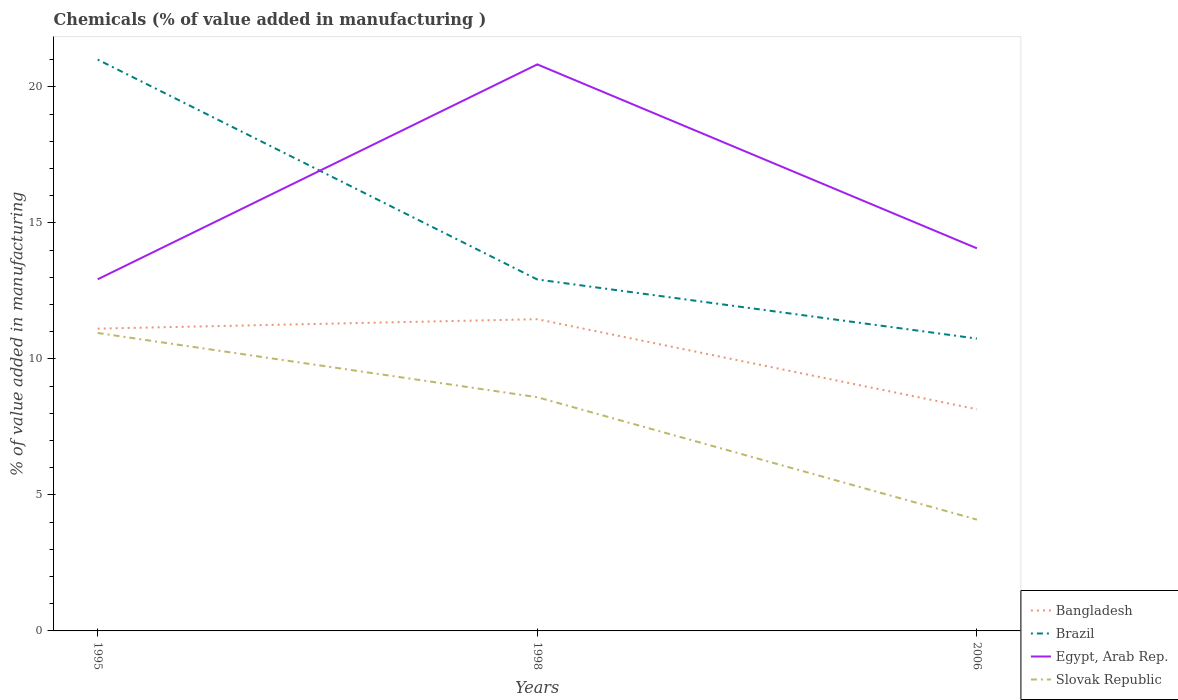Does the line corresponding to Bangladesh intersect with the line corresponding to Slovak Republic?
Give a very brief answer. No. Across all years, what is the maximum value added in manufacturing chemicals in Bangladesh?
Ensure brevity in your answer.  8.15. What is the total value added in manufacturing chemicals in Brazil in the graph?
Your answer should be very brief. 8.09. What is the difference between the highest and the second highest value added in manufacturing chemicals in Brazil?
Keep it short and to the point. 10.26. What is the difference between the highest and the lowest value added in manufacturing chemicals in Egypt, Arab Rep.?
Make the answer very short. 1. Is the value added in manufacturing chemicals in Slovak Republic strictly greater than the value added in manufacturing chemicals in Bangladesh over the years?
Ensure brevity in your answer.  Yes. How many lines are there?
Give a very brief answer. 4. What is the difference between two consecutive major ticks on the Y-axis?
Make the answer very short. 5. Are the values on the major ticks of Y-axis written in scientific E-notation?
Keep it short and to the point. No. Does the graph contain grids?
Your response must be concise. No. Where does the legend appear in the graph?
Keep it short and to the point. Bottom right. How are the legend labels stacked?
Your answer should be compact. Vertical. What is the title of the graph?
Make the answer very short. Chemicals (% of value added in manufacturing ). Does "Sierra Leone" appear as one of the legend labels in the graph?
Keep it short and to the point. No. What is the label or title of the X-axis?
Provide a short and direct response. Years. What is the label or title of the Y-axis?
Keep it short and to the point. % of value added in manufacturing. What is the % of value added in manufacturing of Bangladesh in 1995?
Ensure brevity in your answer.  11.11. What is the % of value added in manufacturing in Brazil in 1995?
Provide a short and direct response. 21.01. What is the % of value added in manufacturing in Egypt, Arab Rep. in 1995?
Your answer should be very brief. 12.93. What is the % of value added in manufacturing of Slovak Republic in 1995?
Provide a short and direct response. 10.96. What is the % of value added in manufacturing of Bangladesh in 1998?
Make the answer very short. 11.46. What is the % of value added in manufacturing of Brazil in 1998?
Provide a short and direct response. 12.92. What is the % of value added in manufacturing in Egypt, Arab Rep. in 1998?
Your answer should be very brief. 20.83. What is the % of value added in manufacturing of Slovak Republic in 1998?
Make the answer very short. 8.59. What is the % of value added in manufacturing of Bangladesh in 2006?
Your answer should be very brief. 8.15. What is the % of value added in manufacturing in Brazil in 2006?
Provide a succinct answer. 10.75. What is the % of value added in manufacturing of Egypt, Arab Rep. in 2006?
Your answer should be very brief. 14.07. What is the % of value added in manufacturing in Slovak Republic in 2006?
Your response must be concise. 4.09. Across all years, what is the maximum % of value added in manufacturing of Bangladesh?
Make the answer very short. 11.46. Across all years, what is the maximum % of value added in manufacturing of Brazil?
Your answer should be compact. 21.01. Across all years, what is the maximum % of value added in manufacturing of Egypt, Arab Rep.?
Provide a short and direct response. 20.83. Across all years, what is the maximum % of value added in manufacturing in Slovak Republic?
Provide a succinct answer. 10.96. Across all years, what is the minimum % of value added in manufacturing of Bangladesh?
Provide a short and direct response. 8.15. Across all years, what is the minimum % of value added in manufacturing in Brazil?
Keep it short and to the point. 10.75. Across all years, what is the minimum % of value added in manufacturing of Egypt, Arab Rep.?
Your answer should be compact. 12.93. Across all years, what is the minimum % of value added in manufacturing of Slovak Republic?
Give a very brief answer. 4.09. What is the total % of value added in manufacturing in Bangladesh in the graph?
Give a very brief answer. 30.73. What is the total % of value added in manufacturing of Brazil in the graph?
Make the answer very short. 44.68. What is the total % of value added in manufacturing of Egypt, Arab Rep. in the graph?
Provide a short and direct response. 47.83. What is the total % of value added in manufacturing of Slovak Republic in the graph?
Your answer should be very brief. 23.64. What is the difference between the % of value added in manufacturing of Bangladesh in 1995 and that in 1998?
Your response must be concise. -0.35. What is the difference between the % of value added in manufacturing in Brazil in 1995 and that in 1998?
Give a very brief answer. 8.09. What is the difference between the % of value added in manufacturing in Egypt, Arab Rep. in 1995 and that in 1998?
Provide a short and direct response. -7.9. What is the difference between the % of value added in manufacturing in Slovak Republic in 1995 and that in 1998?
Give a very brief answer. 2.36. What is the difference between the % of value added in manufacturing in Bangladesh in 1995 and that in 2006?
Provide a succinct answer. 2.96. What is the difference between the % of value added in manufacturing of Brazil in 1995 and that in 2006?
Give a very brief answer. 10.26. What is the difference between the % of value added in manufacturing of Egypt, Arab Rep. in 1995 and that in 2006?
Provide a succinct answer. -1.14. What is the difference between the % of value added in manufacturing of Slovak Republic in 1995 and that in 2006?
Your response must be concise. 6.86. What is the difference between the % of value added in manufacturing in Bangladesh in 1998 and that in 2006?
Your answer should be compact. 3.31. What is the difference between the % of value added in manufacturing in Brazil in 1998 and that in 2006?
Offer a terse response. 2.17. What is the difference between the % of value added in manufacturing in Egypt, Arab Rep. in 1998 and that in 2006?
Your answer should be very brief. 6.76. What is the difference between the % of value added in manufacturing in Slovak Republic in 1998 and that in 2006?
Give a very brief answer. 4.5. What is the difference between the % of value added in manufacturing of Bangladesh in 1995 and the % of value added in manufacturing of Brazil in 1998?
Make the answer very short. -1.81. What is the difference between the % of value added in manufacturing of Bangladesh in 1995 and the % of value added in manufacturing of Egypt, Arab Rep. in 1998?
Provide a short and direct response. -9.72. What is the difference between the % of value added in manufacturing in Bangladesh in 1995 and the % of value added in manufacturing in Slovak Republic in 1998?
Make the answer very short. 2.52. What is the difference between the % of value added in manufacturing of Brazil in 1995 and the % of value added in manufacturing of Egypt, Arab Rep. in 1998?
Offer a terse response. 0.18. What is the difference between the % of value added in manufacturing of Brazil in 1995 and the % of value added in manufacturing of Slovak Republic in 1998?
Offer a very short reply. 12.41. What is the difference between the % of value added in manufacturing in Egypt, Arab Rep. in 1995 and the % of value added in manufacturing in Slovak Republic in 1998?
Give a very brief answer. 4.34. What is the difference between the % of value added in manufacturing in Bangladesh in 1995 and the % of value added in manufacturing in Brazil in 2006?
Your answer should be very brief. 0.37. What is the difference between the % of value added in manufacturing of Bangladesh in 1995 and the % of value added in manufacturing of Egypt, Arab Rep. in 2006?
Keep it short and to the point. -2.95. What is the difference between the % of value added in manufacturing of Bangladesh in 1995 and the % of value added in manufacturing of Slovak Republic in 2006?
Provide a succinct answer. 7.02. What is the difference between the % of value added in manufacturing of Brazil in 1995 and the % of value added in manufacturing of Egypt, Arab Rep. in 2006?
Make the answer very short. 6.94. What is the difference between the % of value added in manufacturing of Brazil in 1995 and the % of value added in manufacturing of Slovak Republic in 2006?
Make the answer very short. 16.92. What is the difference between the % of value added in manufacturing of Egypt, Arab Rep. in 1995 and the % of value added in manufacturing of Slovak Republic in 2006?
Your response must be concise. 8.84. What is the difference between the % of value added in manufacturing of Bangladesh in 1998 and the % of value added in manufacturing of Brazil in 2006?
Offer a terse response. 0.71. What is the difference between the % of value added in manufacturing in Bangladesh in 1998 and the % of value added in manufacturing in Egypt, Arab Rep. in 2006?
Keep it short and to the point. -2.61. What is the difference between the % of value added in manufacturing in Bangladesh in 1998 and the % of value added in manufacturing in Slovak Republic in 2006?
Make the answer very short. 7.37. What is the difference between the % of value added in manufacturing in Brazil in 1998 and the % of value added in manufacturing in Egypt, Arab Rep. in 2006?
Your response must be concise. -1.15. What is the difference between the % of value added in manufacturing of Brazil in 1998 and the % of value added in manufacturing of Slovak Republic in 2006?
Your response must be concise. 8.83. What is the difference between the % of value added in manufacturing in Egypt, Arab Rep. in 1998 and the % of value added in manufacturing in Slovak Republic in 2006?
Make the answer very short. 16.74. What is the average % of value added in manufacturing of Bangladesh per year?
Provide a succinct answer. 10.24. What is the average % of value added in manufacturing of Brazil per year?
Keep it short and to the point. 14.89. What is the average % of value added in manufacturing in Egypt, Arab Rep. per year?
Keep it short and to the point. 15.94. What is the average % of value added in manufacturing in Slovak Republic per year?
Your answer should be compact. 7.88. In the year 1995, what is the difference between the % of value added in manufacturing in Bangladesh and % of value added in manufacturing in Brazil?
Provide a short and direct response. -9.89. In the year 1995, what is the difference between the % of value added in manufacturing in Bangladesh and % of value added in manufacturing in Egypt, Arab Rep.?
Provide a succinct answer. -1.81. In the year 1995, what is the difference between the % of value added in manufacturing of Bangladesh and % of value added in manufacturing of Slovak Republic?
Provide a succinct answer. 0.16. In the year 1995, what is the difference between the % of value added in manufacturing in Brazil and % of value added in manufacturing in Egypt, Arab Rep.?
Provide a succinct answer. 8.08. In the year 1995, what is the difference between the % of value added in manufacturing in Brazil and % of value added in manufacturing in Slovak Republic?
Offer a very short reply. 10.05. In the year 1995, what is the difference between the % of value added in manufacturing in Egypt, Arab Rep. and % of value added in manufacturing in Slovak Republic?
Make the answer very short. 1.97. In the year 1998, what is the difference between the % of value added in manufacturing of Bangladesh and % of value added in manufacturing of Brazil?
Give a very brief answer. -1.46. In the year 1998, what is the difference between the % of value added in manufacturing of Bangladesh and % of value added in manufacturing of Egypt, Arab Rep.?
Provide a succinct answer. -9.37. In the year 1998, what is the difference between the % of value added in manufacturing of Bangladesh and % of value added in manufacturing of Slovak Republic?
Make the answer very short. 2.87. In the year 1998, what is the difference between the % of value added in manufacturing of Brazil and % of value added in manufacturing of Egypt, Arab Rep.?
Make the answer very short. -7.91. In the year 1998, what is the difference between the % of value added in manufacturing of Brazil and % of value added in manufacturing of Slovak Republic?
Your answer should be very brief. 4.33. In the year 1998, what is the difference between the % of value added in manufacturing in Egypt, Arab Rep. and % of value added in manufacturing in Slovak Republic?
Provide a short and direct response. 12.24. In the year 2006, what is the difference between the % of value added in manufacturing in Bangladesh and % of value added in manufacturing in Brazil?
Your answer should be very brief. -2.6. In the year 2006, what is the difference between the % of value added in manufacturing of Bangladesh and % of value added in manufacturing of Egypt, Arab Rep.?
Make the answer very short. -5.92. In the year 2006, what is the difference between the % of value added in manufacturing of Bangladesh and % of value added in manufacturing of Slovak Republic?
Ensure brevity in your answer.  4.06. In the year 2006, what is the difference between the % of value added in manufacturing of Brazil and % of value added in manufacturing of Egypt, Arab Rep.?
Keep it short and to the point. -3.32. In the year 2006, what is the difference between the % of value added in manufacturing in Brazil and % of value added in manufacturing in Slovak Republic?
Your answer should be compact. 6.66. In the year 2006, what is the difference between the % of value added in manufacturing of Egypt, Arab Rep. and % of value added in manufacturing of Slovak Republic?
Keep it short and to the point. 9.98. What is the ratio of the % of value added in manufacturing of Bangladesh in 1995 to that in 1998?
Offer a very short reply. 0.97. What is the ratio of the % of value added in manufacturing in Brazil in 1995 to that in 1998?
Ensure brevity in your answer.  1.63. What is the ratio of the % of value added in manufacturing of Egypt, Arab Rep. in 1995 to that in 1998?
Make the answer very short. 0.62. What is the ratio of the % of value added in manufacturing of Slovak Republic in 1995 to that in 1998?
Provide a succinct answer. 1.27. What is the ratio of the % of value added in manufacturing of Bangladesh in 1995 to that in 2006?
Your answer should be very brief. 1.36. What is the ratio of the % of value added in manufacturing in Brazil in 1995 to that in 2006?
Provide a succinct answer. 1.95. What is the ratio of the % of value added in manufacturing in Egypt, Arab Rep. in 1995 to that in 2006?
Ensure brevity in your answer.  0.92. What is the ratio of the % of value added in manufacturing in Slovak Republic in 1995 to that in 2006?
Offer a very short reply. 2.68. What is the ratio of the % of value added in manufacturing of Bangladesh in 1998 to that in 2006?
Ensure brevity in your answer.  1.41. What is the ratio of the % of value added in manufacturing of Brazil in 1998 to that in 2006?
Your response must be concise. 1.2. What is the ratio of the % of value added in manufacturing in Egypt, Arab Rep. in 1998 to that in 2006?
Your answer should be compact. 1.48. What is the ratio of the % of value added in manufacturing of Slovak Republic in 1998 to that in 2006?
Your answer should be compact. 2.1. What is the difference between the highest and the second highest % of value added in manufacturing of Bangladesh?
Your response must be concise. 0.35. What is the difference between the highest and the second highest % of value added in manufacturing in Brazil?
Your answer should be compact. 8.09. What is the difference between the highest and the second highest % of value added in manufacturing of Egypt, Arab Rep.?
Your response must be concise. 6.76. What is the difference between the highest and the second highest % of value added in manufacturing in Slovak Republic?
Provide a succinct answer. 2.36. What is the difference between the highest and the lowest % of value added in manufacturing in Bangladesh?
Offer a very short reply. 3.31. What is the difference between the highest and the lowest % of value added in manufacturing of Brazil?
Make the answer very short. 10.26. What is the difference between the highest and the lowest % of value added in manufacturing in Egypt, Arab Rep.?
Provide a succinct answer. 7.9. What is the difference between the highest and the lowest % of value added in manufacturing in Slovak Republic?
Offer a very short reply. 6.86. 